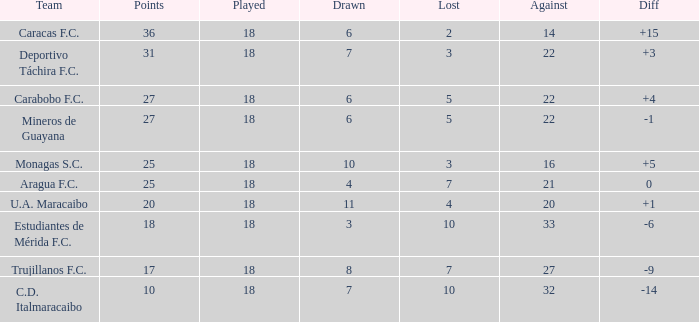What is the average against score of all teams with less than 7 losses, more than 6 draws, and 25 points? 16.0. Could you parse the entire table as a dict? {'header': ['Team', 'Points', 'Played', 'Drawn', 'Lost', 'Against', 'Diff'], 'rows': [['Caracas F.C.', '36', '18', '6', '2', '14', '+15'], ['Deportivo Táchira F.C.', '31', '18', '7', '3', '22', '+3'], ['Carabobo F.C.', '27', '18', '6', '5', '22', '+4'], ['Mineros de Guayana', '27', '18', '6', '5', '22', '-1'], ['Monagas S.C.', '25', '18', '10', '3', '16', '+5'], ['Aragua F.C.', '25', '18', '4', '7', '21', '0'], ['U.A. Maracaibo', '20', '18', '11', '4', '20', '+1'], ['Estudiantes de Mérida F.C.', '18', '18', '3', '10', '33', '-6'], ['Trujillanos F.C.', '17', '18', '8', '7', '27', '-9'], ['C.D. Italmaracaibo', '10', '18', '7', '10', '32', '-14']]} 